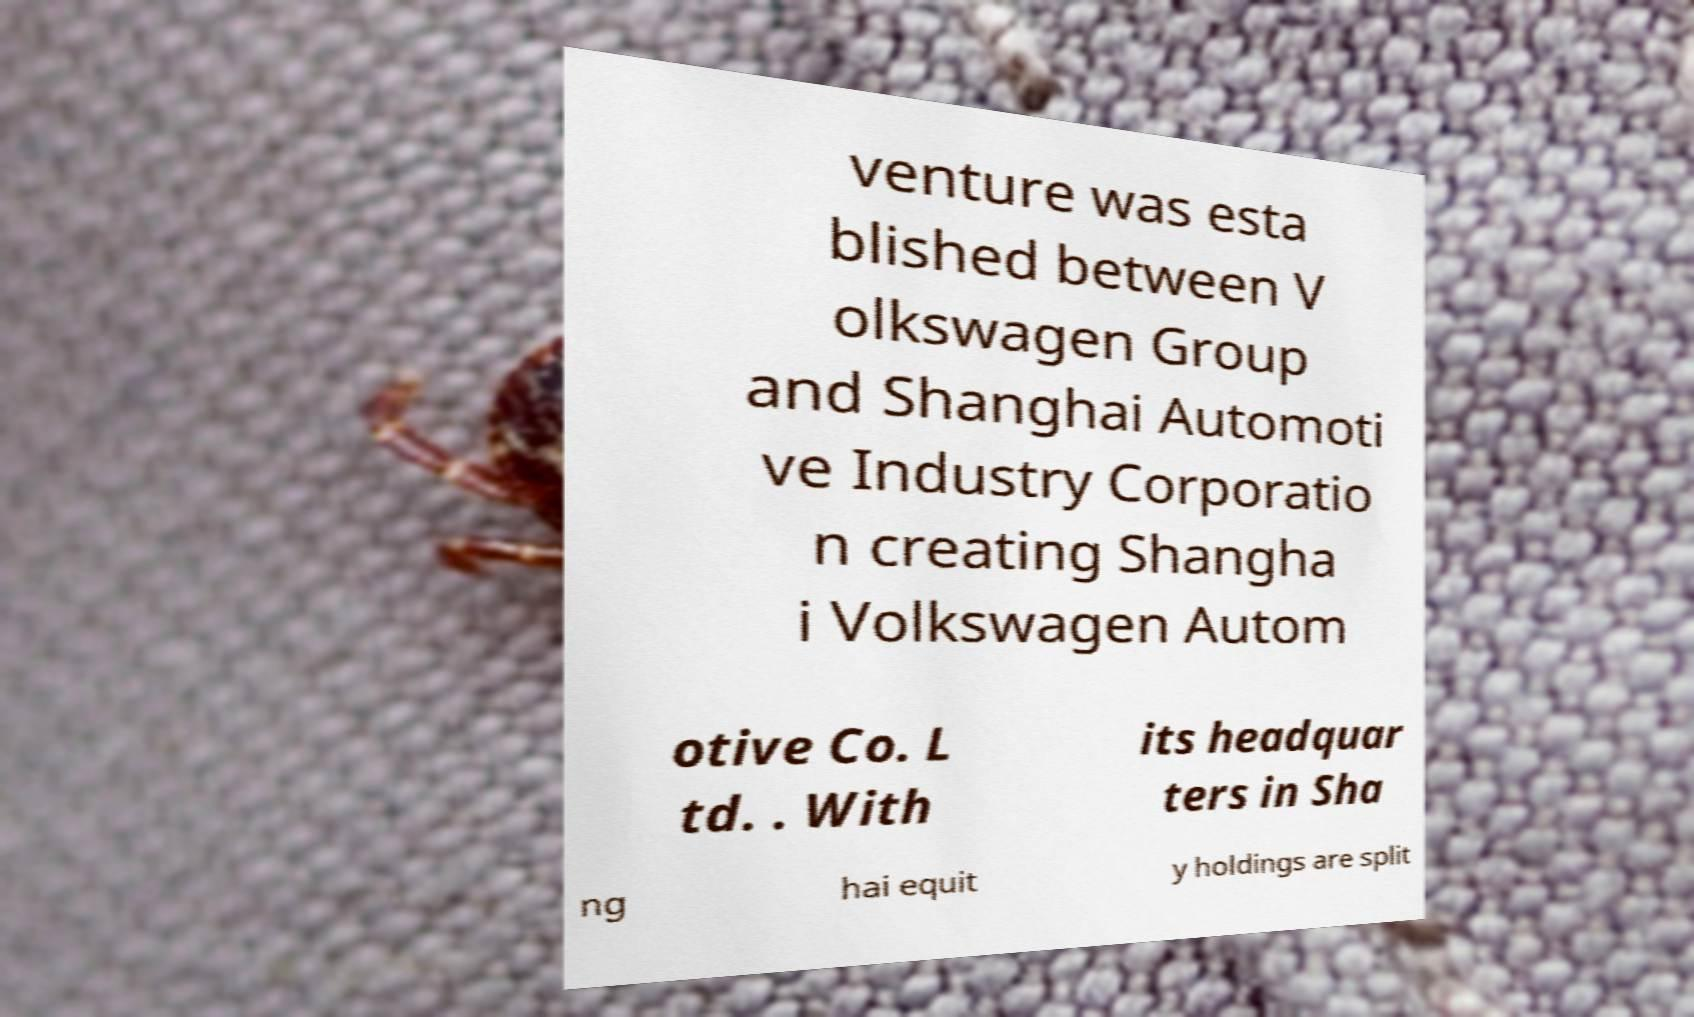Can you read and provide the text displayed in the image?This photo seems to have some interesting text. Can you extract and type it out for me? venture was esta blished between V olkswagen Group and Shanghai Automoti ve Industry Corporatio n creating Shangha i Volkswagen Autom otive Co. L td. . With its headquar ters in Sha ng hai equit y holdings are split 